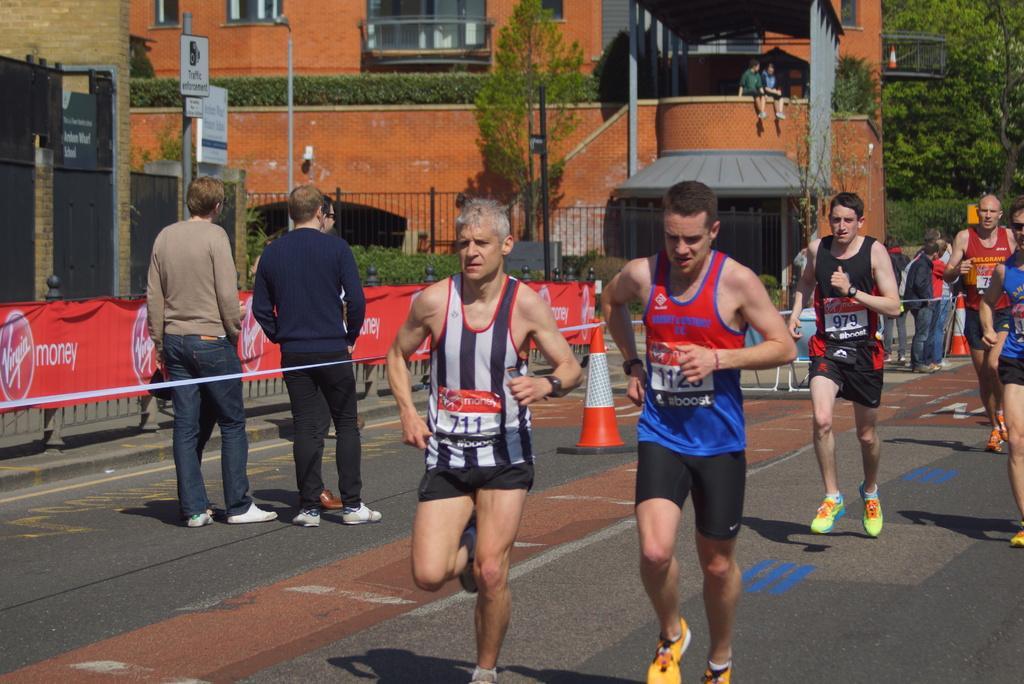How would you summarize this image in a sentence or two? In this image in the center there are some people who are running, and there are some people standing and there is a tape and barricades and in the background there are buildings, trees, poles and some boards and plants. And on the left side of the image there is a railing and banner, at the bottom there is walkway. 